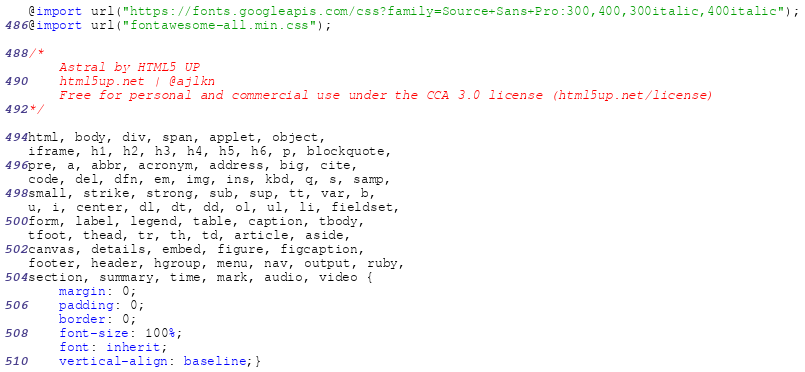<code> <loc_0><loc_0><loc_500><loc_500><_CSS_>@import url("https://fonts.googleapis.com/css?family=Source+Sans+Pro:300,400,300italic,400italic");
@import url("fontawesome-all.min.css");

/*
	Astral by HTML5 UP
	html5up.net | @ajlkn
	Free for personal and commercial use under the CCA 3.0 license (html5up.net/license)
*/

html, body, div, span, applet, object,
iframe, h1, h2, h3, h4, h5, h6, p, blockquote,
pre, a, abbr, acronym, address, big, cite,
code, del, dfn, em, img, ins, kbd, q, s, samp,
small, strike, strong, sub, sup, tt, var, b,
u, i, center, dl, dt, dd, ol, ul, li, fieldset,
form, label, legend, table, caption, tbody,
tfoot, thead, tr, th, td, article, aside,
canvas, details, embed, figure, figcaption,
footer, header, hgroup, menu, nav, output, ruby,
section, summary, time, mark, audio, video {
	margin: 0;
	padding: 0;
	border: 0;
	font-size: 100%;
	font: inherit;
	vertical-align: baseline;}
</code> 